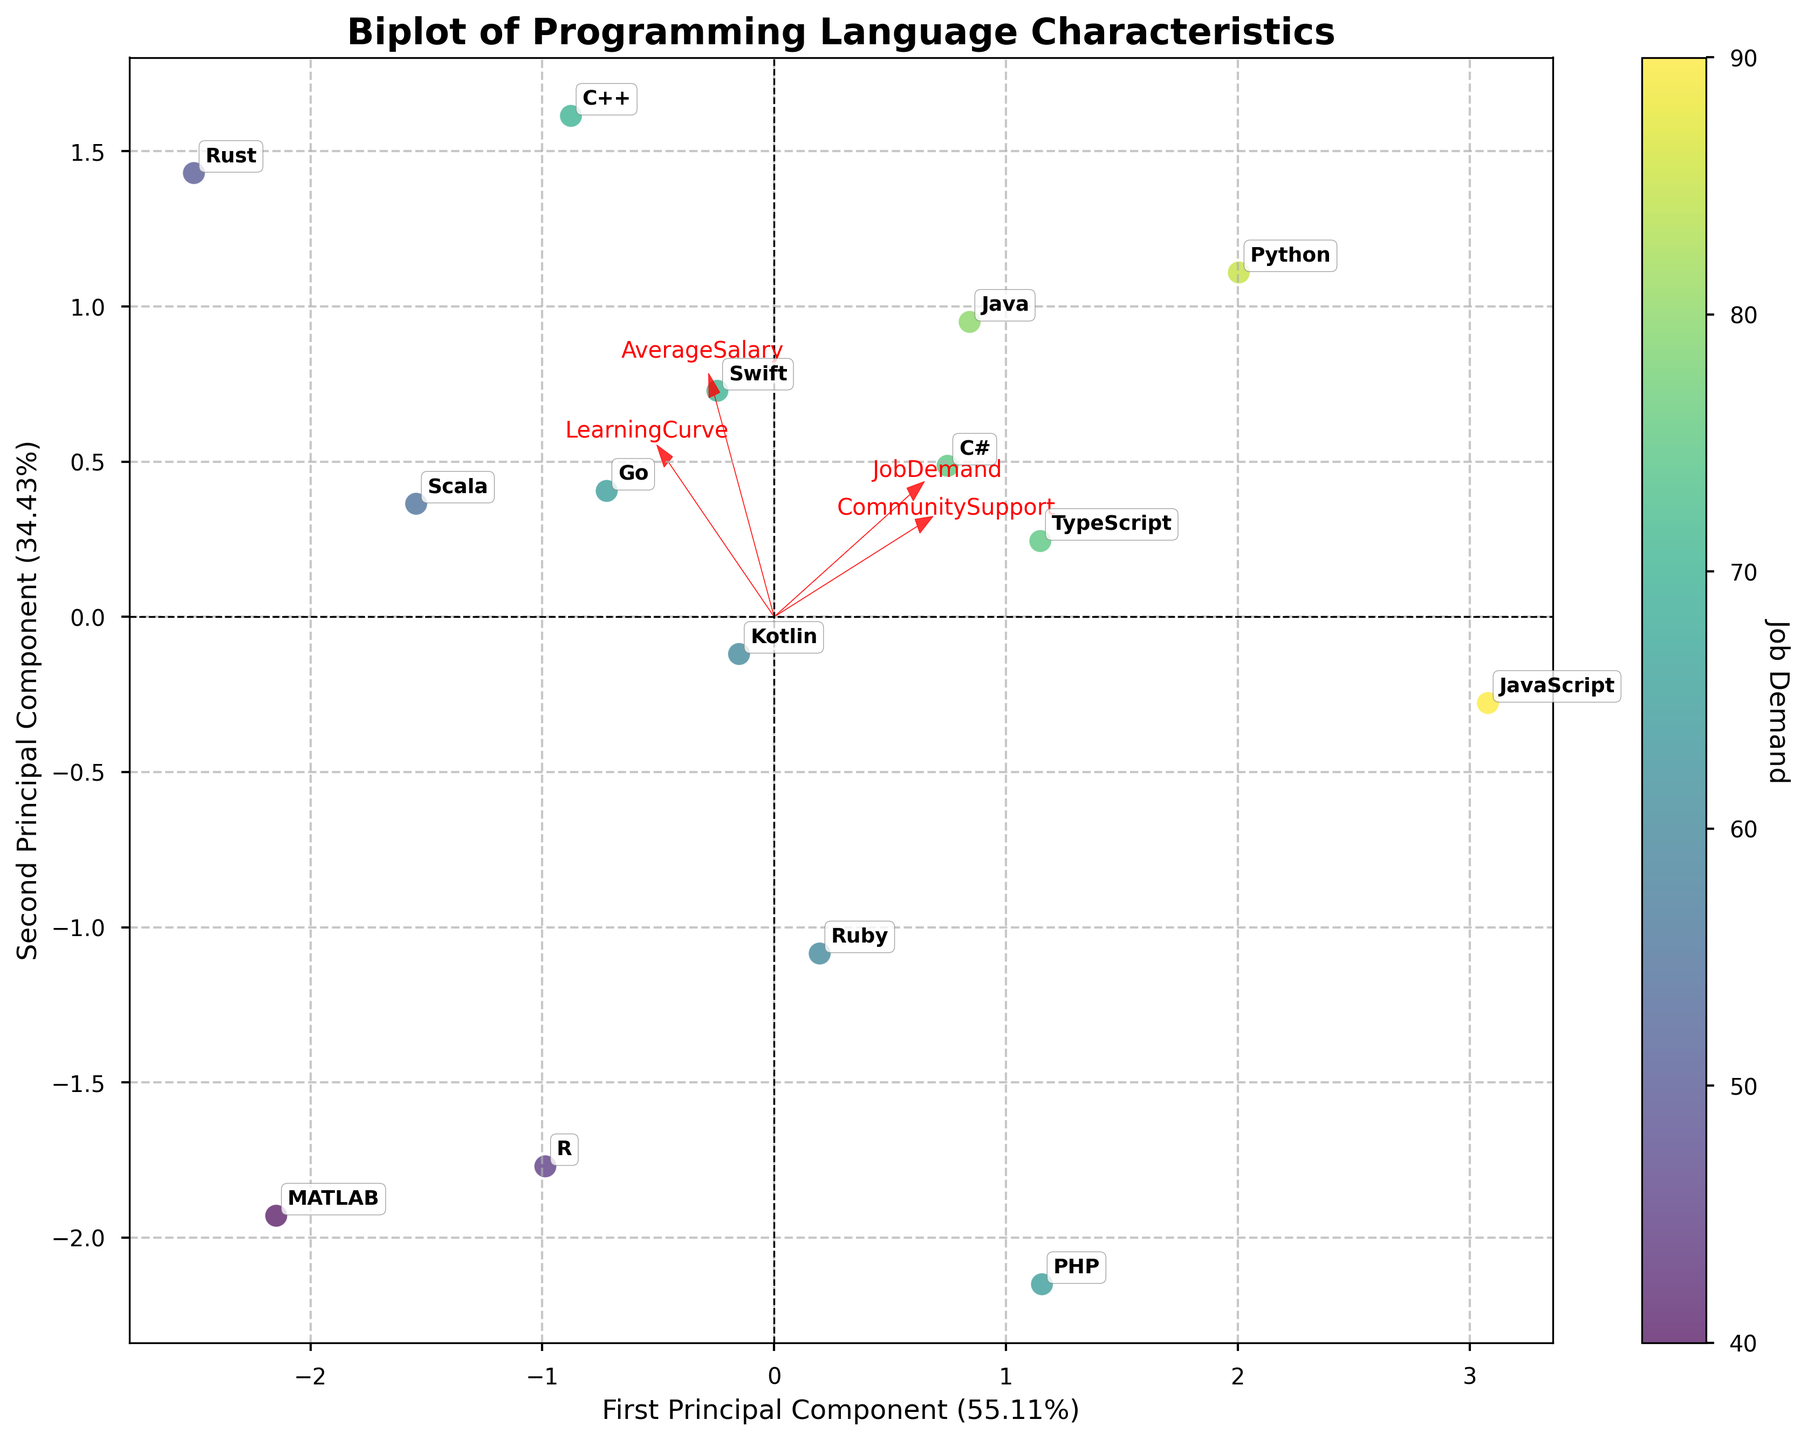How many programming languages are represented on the biplot? Look at the total number of labels corresponding to programming languages on the biplot. Count each unique label.
Answer: 15 Which programming language has the highest job demand? Find the language label associated with the data point that has the highest color intensity, corresponding to the highest job demand.
Answer: JavaScript What are the two principal components representing on the axes? Look at the axis labels to determine what they represent: the percentage of variance explained by each principal component.
Answer: First Principal Component (X-axis), Second Principal Component (Y-axis) Which feature has the greatest influence on the first principal component? Look at the direction and length of the arrows representing the features. The feature with the arrow extending furthest along the X-axis has the greatest influence on the first principal component.
Answer: Job Demand Compare the 'Average Salary' between Python and Java. Which language offers a higher average salary? Locate Python and Java on the biplot and compare their positions in relation to the 'Average Salary' arrow. The language closer to the arrow’s positive direction has the higher average salary.
Answer: Python What is the relationship between the 'LearningCurve' and the second principal component? Observe the direction of the 'LearningCurve' arrow relative to the Y-axis. If it's aligned with the Y-axis, it indicates a strong relationship. Otherwise, it shows a lesser or negative relationship.
Answer: Moderate positive relationship Which programming language has a similar job demand to TypeScript but a higher average salary? Identify the position of TypeScript based on its color intensity for job demand, then find another language close in color but located further in the positive direction of the 'Average Salary' arrow.
Answer: C++ Which feature appears to have the least influence on both principal components? Look for the shortest arrow amongst the features. The shortest arrow has the least influence on both components.
Answer: Community Support Which languages are clustered together, indicating similar profiles based on the features? Observe the languages that are closely positioned on the biplot. Clustering suggests they have similar profiles in job demand, average salary, learning curve, and community support.
Answer: Java, C#, and TypeScript Considering the position of Rust on the biplot, explain its general profile in terms of the four features. Rust's position in relation to the feature arrows can help infer its profile. Far from 'Job Demand' and 'Community Support' arrows but close to 'Average Salary' and 'LearningCurve' arrows indicate:
Answer: High salary, difficult to learn, moderate job demand, low community support 